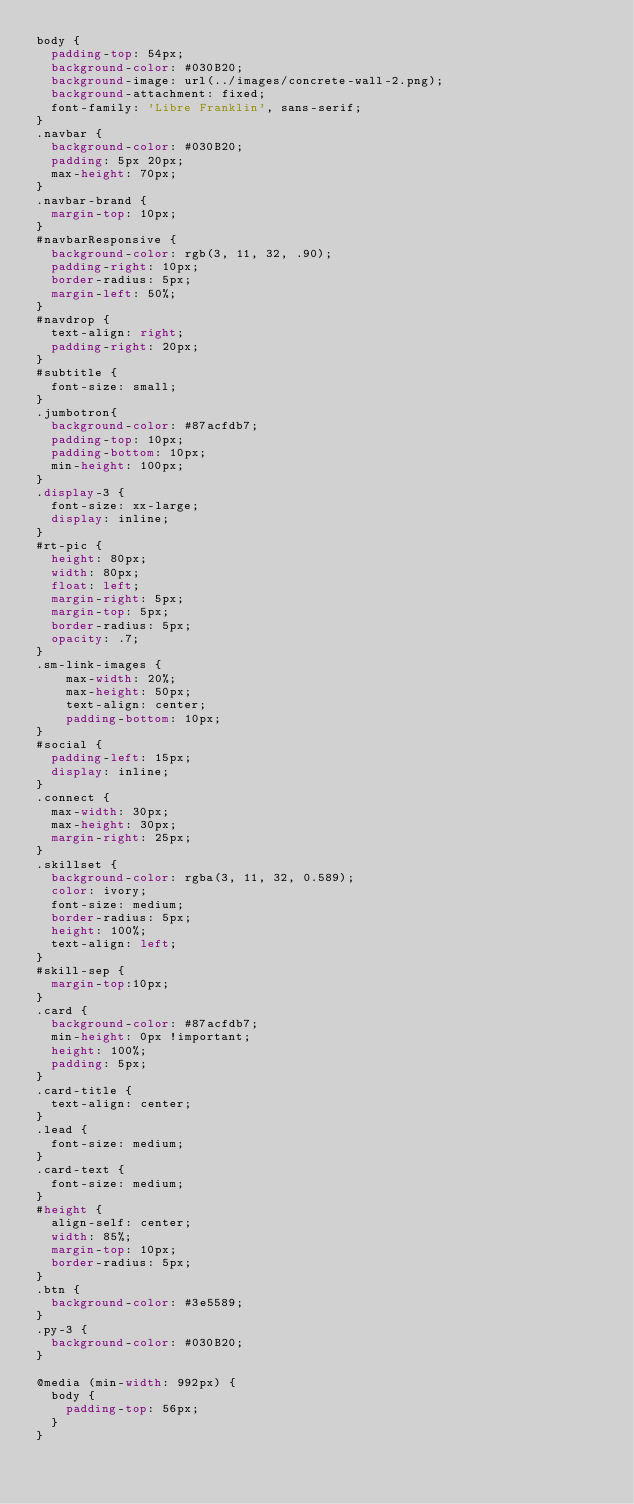<code> <loc_0><loc_0><loc_500><loc_500><_CSS_>body {
  padding-top: 54px;
  background-color: #030B20;
  background-image: url(../images/concrete-wall-2.png);
  background-attachment: fixed;
  font-family: 'Libre Franklin', sans-serif;
}
.navbar {
  background-color: #030B20;
  padding: 5px 20px;
  max-height: 70px;
}
.navbar-brand {
  margin-top: 10px;
}
#navbarResponsive {
  background-color: rgb(3, 11, 32, .90);
  padding-right: 10px;
  border-radius: 5px;
  margin-left: 50%;
}
#navdrop {
  text-align: right;
  padding-right: 20px;
}
#subtitle {
  font-size: small;
}
.jumbotron{
  background-color: #87acfdb7;
  padding-top: 10px;
  padding-bottom: 10px;
  min-height: 100px;
}
.display-3 {
  font-size: xx-large;
  display: inline;
}
#rt-pic {
  height: 80px;
  width: 80px;
  float: left;
  margin-right: 5px;
  margin-top: 5px;
  border-radius: 5px;
  opacity: .7;
}
.sm-link-images {
	max-width: 20%;
	max-height: 50px;
	text-align: center;
	padding-bottom: 10px;
}
#social {
  padding-left: 15px;
  display: inline;
}
.connect {
  max-width: 30px;
  max-height: 30px;
  margin-right: 25px;
}
.skillset {
  background-color: rgba(3, 11, 32, 0.589);
  color: ivory;
  font-size: medium;
  border-radius: 5px;
  height: 100%;
  text-align: left;
}
#skill-sep {
  margin-top:10px;
}
.card {
  background-color: #87acfdb7;
  min-height: 0px !important;
  height: 100%;
  padding: 5px;
}
.card-title {
  text-align: center;
}
.lead {
  font-size: medium;
}
.card-text {
  font-size: medium;
}
#height {
  align-self: center;
  width: 85%;
  margin-top: 10px;
  border-radius: 5px;
}
.btn {
  background-color: #3e5589;
}
.py-3 {
  background-color: #030B20;
}

@media (min-width: 992px) {
  body {
    padding-top: 56px;
  }
}</code> 